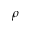Convert formula to latex. <formula><loc_0><loc_0><loc_500><loc_500>\rho</formula> 